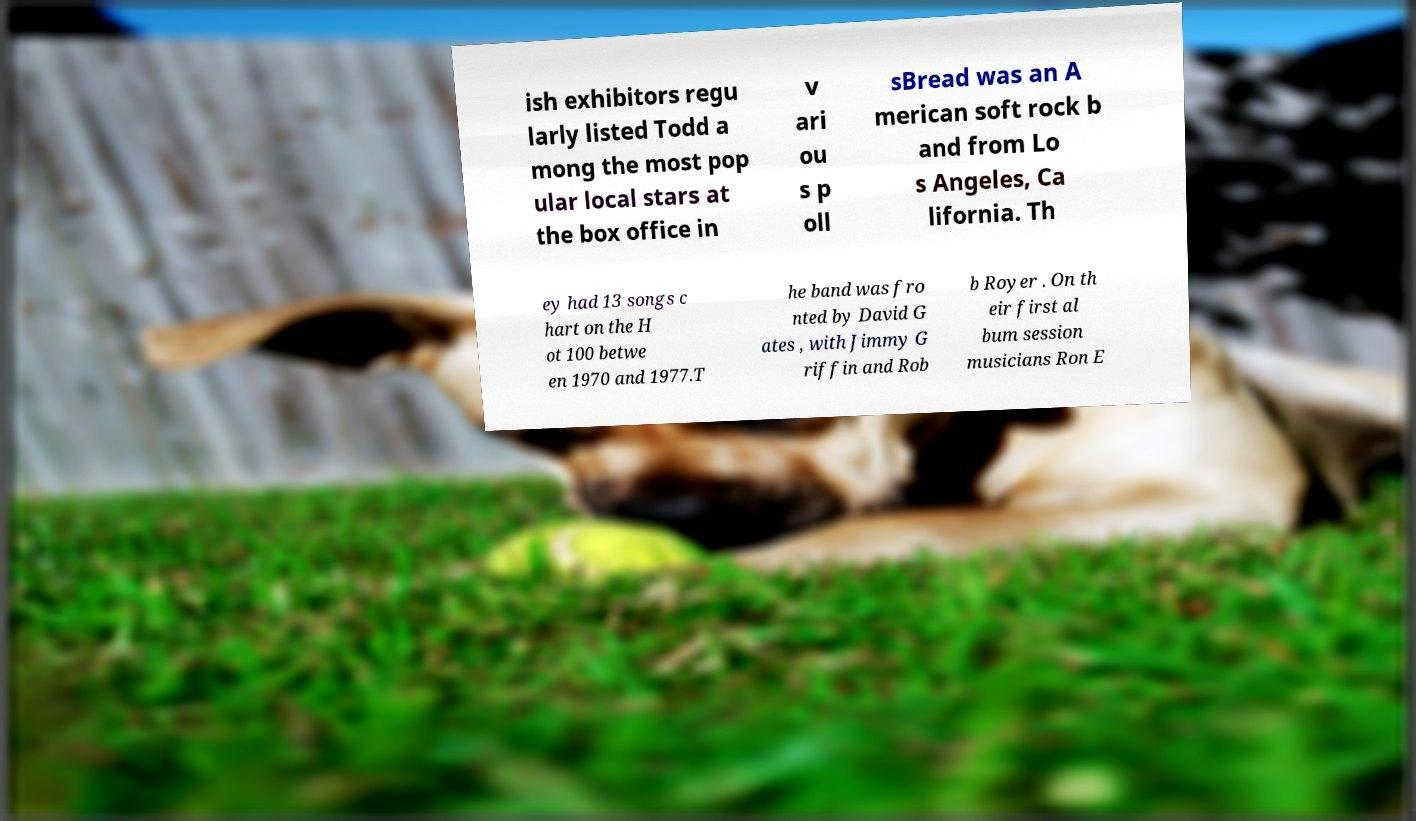Can you accurately transcribe the text from the provided image for me? ish exhibitors regu larly listed Todd a mong the most pop ular local stars at the box office in v ari ou s p oll sBread was an A merican soft rock b and from Lo s Angeles, Ca lifornia. Th ey had 13 songs c hart on the H ot 100 betwe en 1970 and 1977.T he band was fro nted by David G ates , with Jimmy G riffin and Rob b Royer . On th eir first al bum session musicians Ron E 